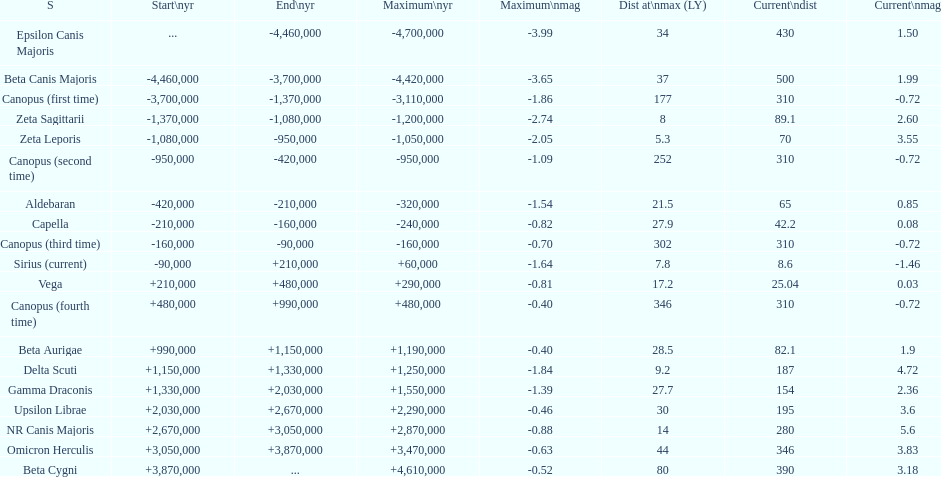What is the difference in the nearest current distance and farthest current distance? 491.4. 